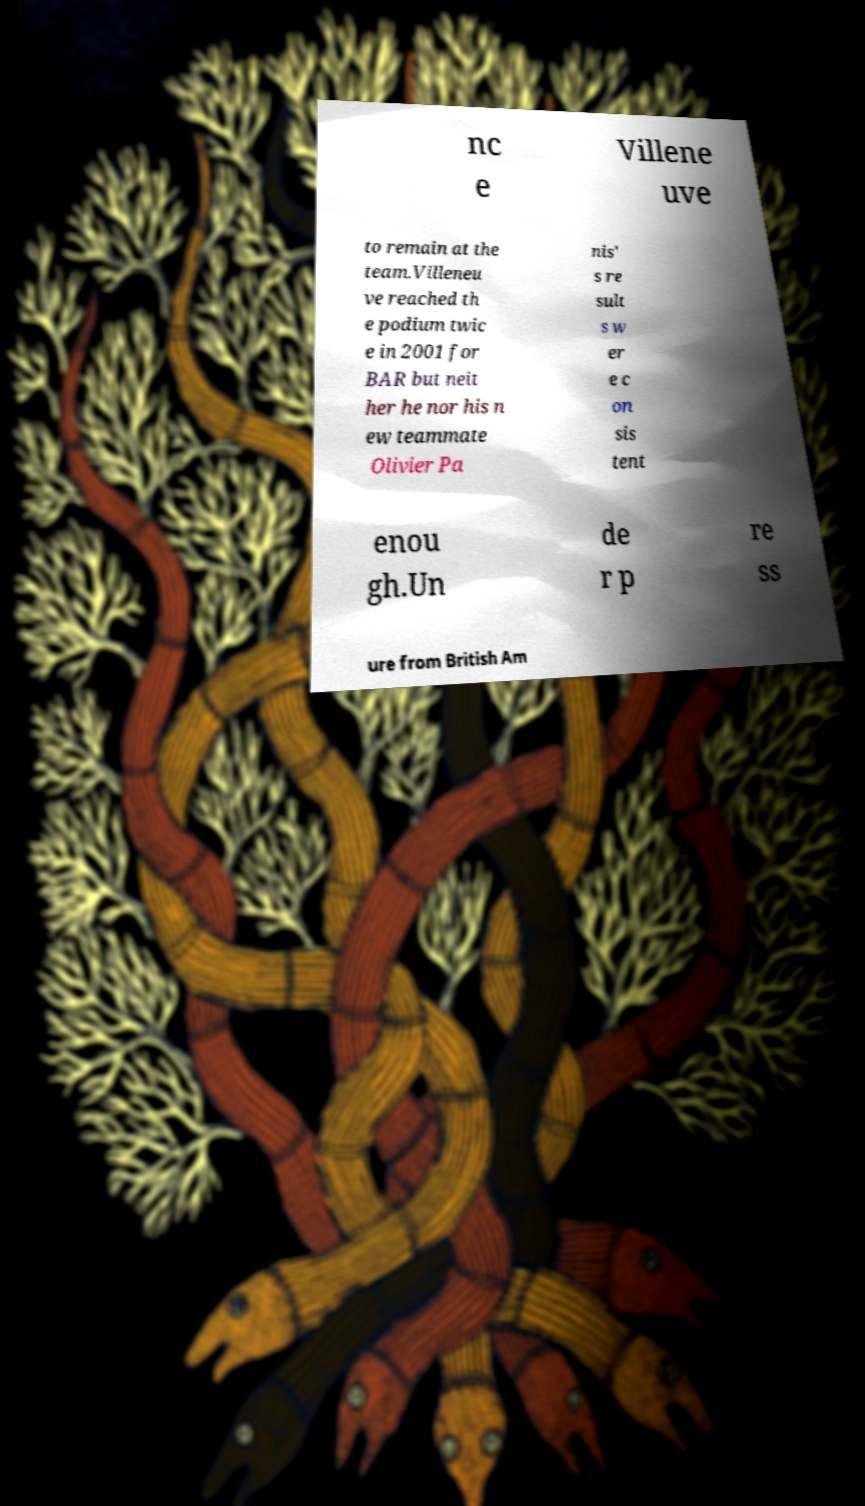Please read and relay the text visible in this image. What does it say? nc e Villene uve to remain at the team.Villeneu ve reached th e podium twic e in 2001 for BAR but neit her he nor his n ew teammate Olivier Pa nis' s re sult s w er e c on sis tent enou gh.Un de r p re ss ure from British Am 